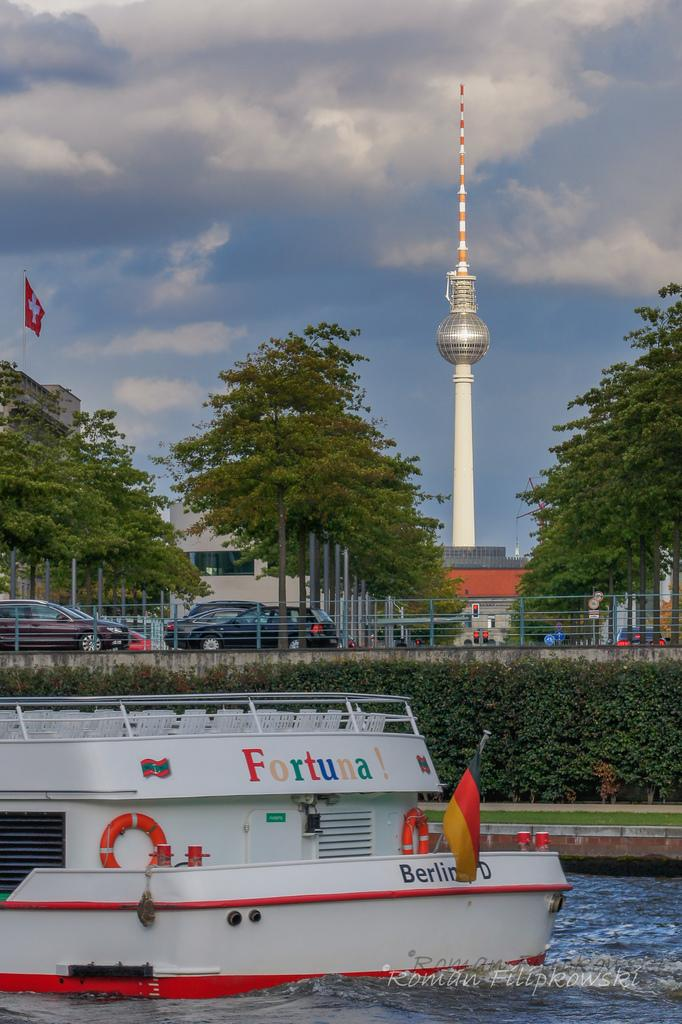<image>
Write a terse but informative summary of the picture. A boat with the name of Fortuna is floating on the water. 